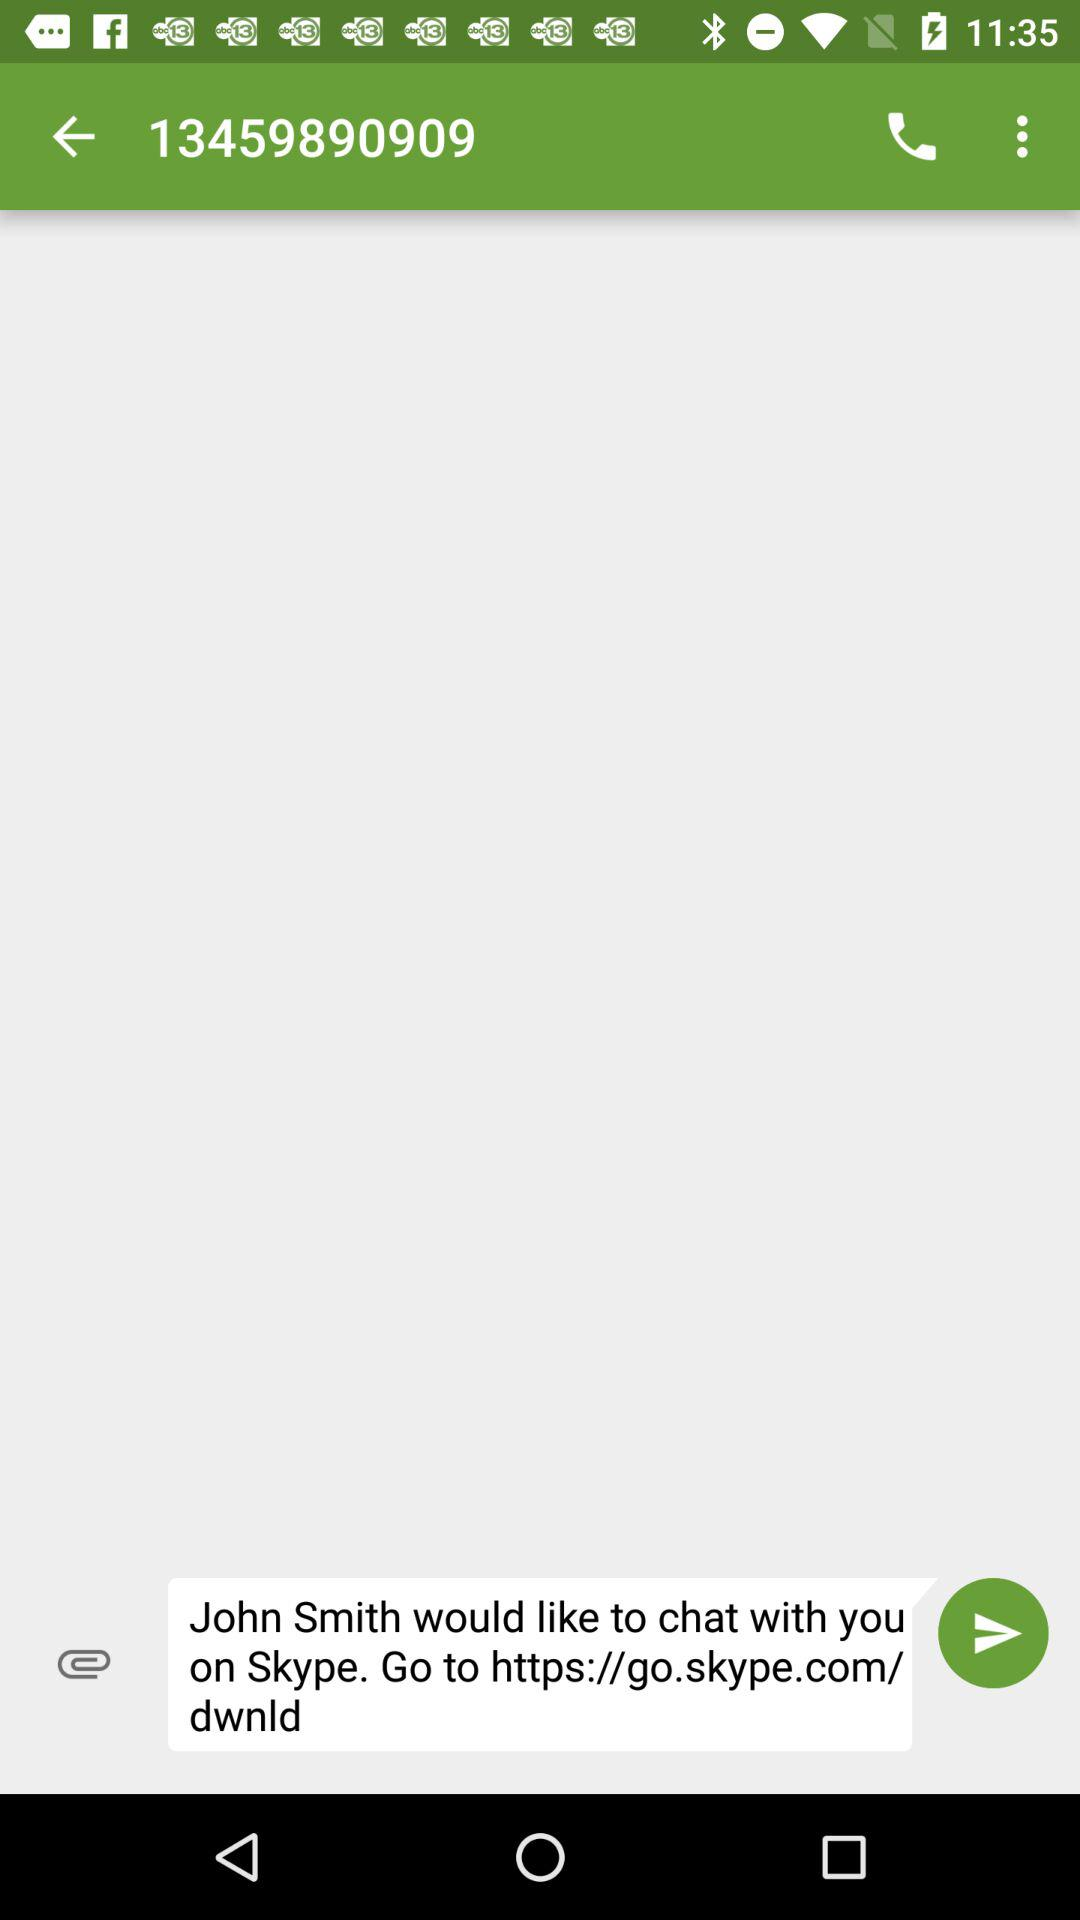What is the phone number? The phone number is 13459890909. 